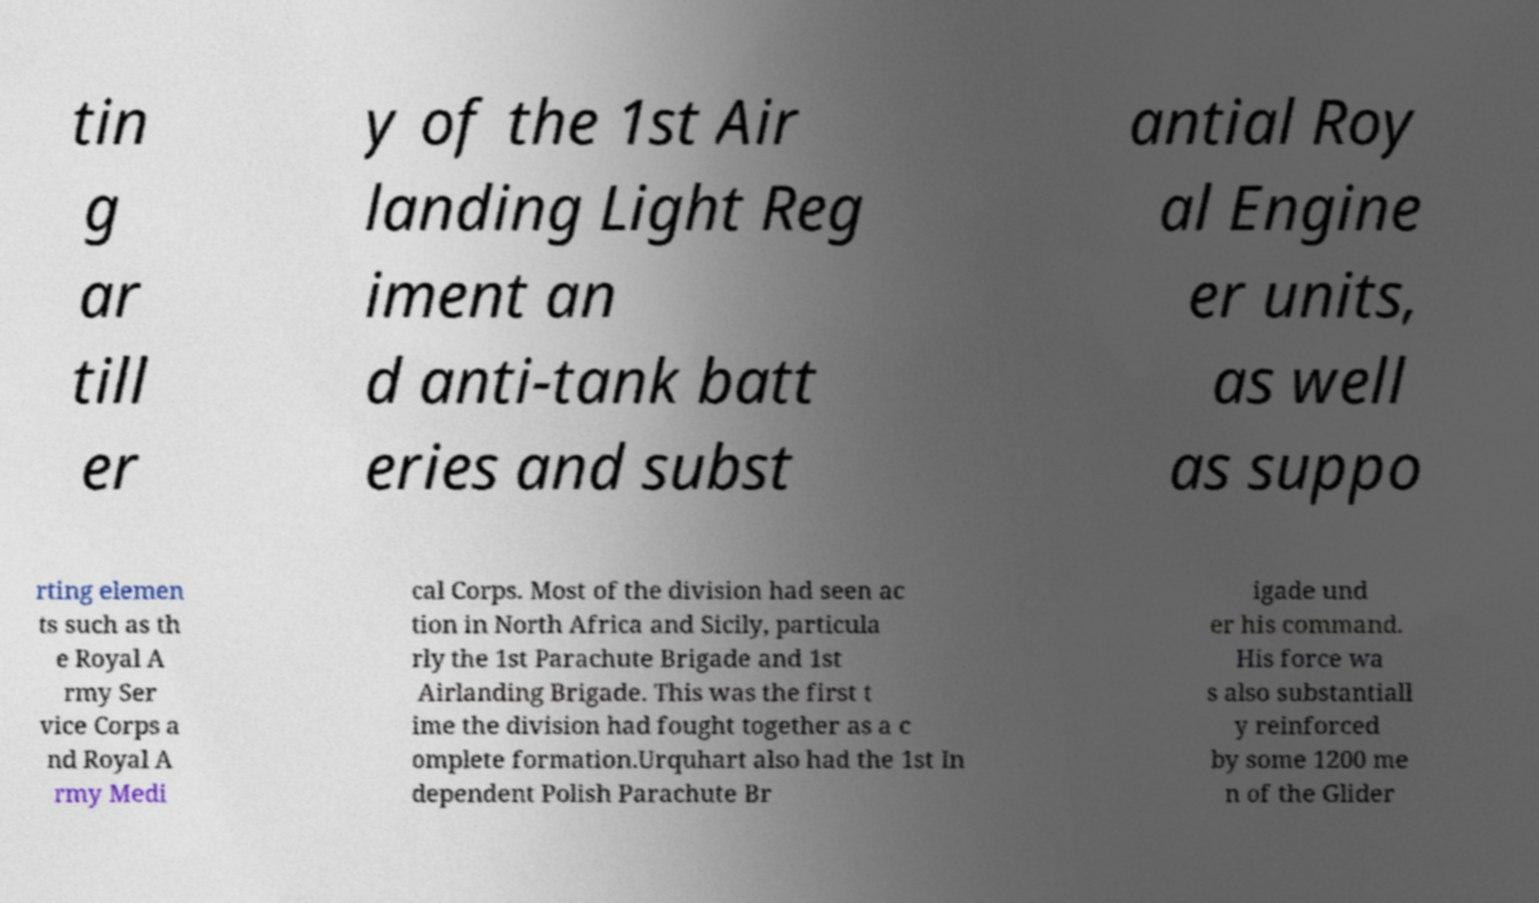Could you assist in decoding the text presented in this image and type it out clearly? tin g ar till er y of the 1st Air landing Light Reg iment an d anti-tank batt eries and subst antial Roy al Engine er units, as well as suppo rting elemen ts such as th e Royal A rmy Ser vice Corps a nd Royal A rmy Medi cal Corps. Most of the division had seen ac tion in North Africa and Sicily, particula rly the 1st Parachute Brigade and 1st Airlanding Brigade. This was the first t ime the division had fought together as a c omplete formation.Urquhart also had the 1st In dependent Polish Parachute Br igade und er his command. His force wa s also substantiall y reinforced by some 1200 me n of the Glider 